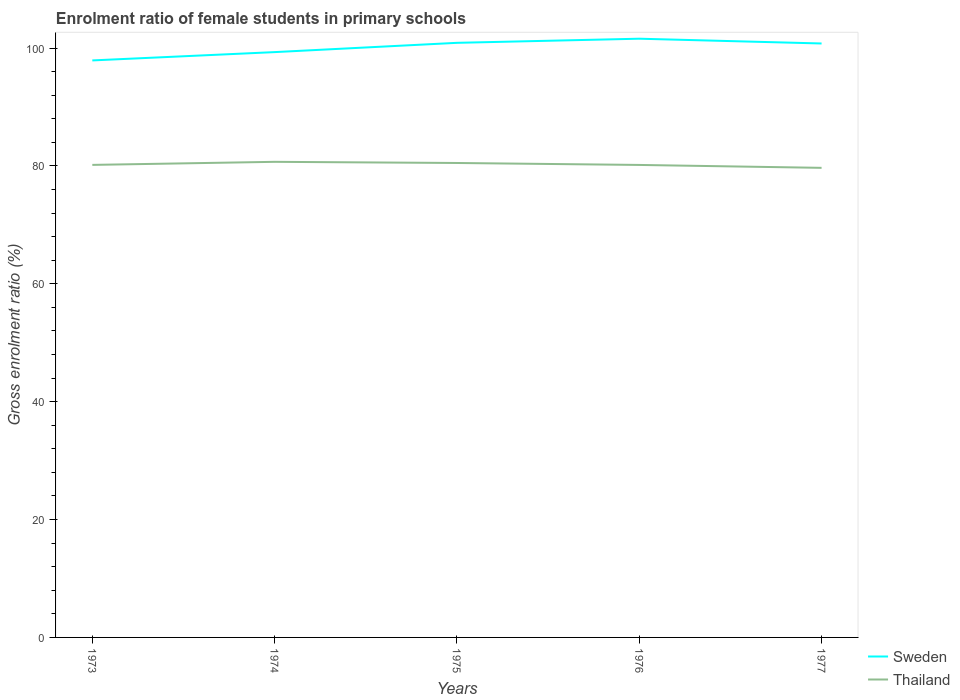How many different coloured lines are there?
Offer a terse response. 2. Across all years, what is the maximum enrolment ratio of female students in primary schools in Sweden?
Give a very brief answer. 97.91. What is the total enrolment ratio of female students in primary schools in Sweden in the graph?
Provide a short and direct response. -1.41. What is the difference between the highest and the second highest enrolment ratio of female students in primary schools in Sweden?
Give a very brief answer. 3.69. Is the enrolment ratio of female students in primary schools in Thailand strictly greater than the enrolment ratio of female students in primary schools in Sweden over the years?
Offer a terse response. Yes. How many years are there in the graph?
Provide a short and direct response. 5. Where does the legend appear in the graph?
Your answer should be very brief. Bottom right. How many legend labels are there?
Offer a terse response. 2. How are the legend labels stacked?
Ensure brevity in your answer.  Vertical. What is the title of the graph?
Provide a short and direct response. Enrolment ratio of female students in primary schools. What is the Gross enrolment ratio (%) of Sweden in 1973?
Make the answer very short. 97.91. What is the Gross enrolment ratio (%) of Thailand in 1973?
Make the answer very short. 80.18. What is the Gross enrolment ratio (%) of Sweden in 1974?
Give a very brief answer. 99.32. What is the Gross enrolment ratio (%) of Thailand in 1974?
Provide a short and direct response. 80.7. What is the Gross enrolment ratio (%) in Sweden in 1975?
Provide a short and direct response. 100.89. What is the Gross enrolment ratio (%) in Thailand in 1975?
Keep it short and to the point. 80.51. What is the Gross enrolment ratio (%) of Sweden in 1976?
Your response must be concise. 101.59. What is the Gross enrolment ratio (%) in Thailand in 1976?
Your answer should be very brief. 80.17. What is the Gross enrolment ratio (%) of Sweden in 1977?
Your answer should be compact. 100.78. What is the Gross enrolment ratio (%) of Thailand in 1977?
Keep it short and to the point. 79.68. Across all years, what is the maximum Gross enrolment ratio (%) in Sweden?
Offer a terse response. 101.59. Across all years, what is the maximum Gross enrolment ratio (%) of Thailand?
Your answer should be very brief. 80.7. Across all years, what is the minimum Gross enrolment ratio (%) in Sweden?
Provide a succinct answer. 97.91. Across all years, what is the minimum Gross enrolment ratio (%) of Thailand?
Your response must be concise. 79.68. What is the total Gross enrolment ratio (%) in Sweden in the graph?
Offer a terse response. 500.49. What is the total Gross enrolment ratio (%) of Thailand in the graph?
Offer a very short reply. 401.24. What is the difference between the Gross enrolment ratio (%) in Sweden in 1973 and that in 1974?
Provide a succinct answer. -1.41. What is the difference between the Gross enrolment ratio (%) of Thailand in 1973 and that in 1974?
Your response must be concise. -0.52. What is the difference between the Gross enrolment ratio (%) in Sweden in 1973 and that in 1975?
Ensure brevity in your answer.  -2.99. What is the difference between the Gross enrolment ratio (%) in Thailand in 1973 and that in 1975?
Make the answer very short. -0.33. What is the difference between the Gross enrolment ratio (%) of Sweden in 1973 and that in 1976?
Offer a terse response. -3.69. What is the difference between the Gross enrolment ratio (%) in Thailand in 1973 and that in 1976?
Make the answer very short. 0.01. What is the difference between the Gross enrolment ratio (%) of Sweden in 1973 and that in 1977?
Your answer should be compact. -2.88. What is the difference between the Gross enrolment ratio (%) in Thailand in 1973 and that in 1977?
Keep it short and to the point. 0.5. What is the difference between the Gross enrolment ratio (%) of Sweden in 1974 and that in 1975?
Keep it short and to the point. -1.57. What is the difference between the Gross enrolment ratio (%) in Thailand in 1974 and that in 1975?
Your answer should be very brief. 0.2. What is the difference between the Gross enrolment ratio (%) of Sweden in 1974 and that in 1976?
Keep it short and to the point. -2.27. What is the difference between the Gross enrolment ratio (%) in Thailand in 1974 and that in 1976?
Offer a terse response. 0.53. What is the difference between the Gross enrolment ratio (%) in Sweden in 1974 and that in 1977?
Make the answer very short. -1.46. What is the difference between the Gross enrolment ratio (%) of Thailand in 1974 and that in 1977?
Your response must be concise. 1.02. What is the difference between the Gross enrolment ratio (%) in Sweden in 1975 and that in 1976?
Offer a very short reply. -0.7. What is the difference between the Gross enrolment ratio (%) of Thailand in 1975 and that in 1976?
Give a very brief answer. 0.33. What is the difference between the Gross enrolment ratio (%) in Sweden in 1975 and that in 1977?
Your response must be concise. 0.11. What is the difference between the Gross enrolment ratio (%) in Thailand in 1975 and that in 1977?
Keep it short and to the point. 0.83. What is the difference between the Gross enrolment ratio (%) in Sweden in 1976 and that in 1977?
Keep it short and to the point. 0.81. What is the difference between the Gross enrolment ratio (%) in Thailand in 1976 and that in 1977?
Offer a terse response. 0.49. What is the difference between the Gross enrolment ratio (%) in Sweden in 1973 and the Gross enrolment ratio (%) in Thailand in 1974?
Your answer should be compact. 17.21. What is the difference between the Gross enrolment ratio (%) of Sweden in 1973 and the Gross enrolment ratio (%) of Thailand in 1975?
Give a very brief answer. 17.4. What is the difference between the Gross enrolment ratio (%) of Sweden in 1973 and the Gross enrolment ratio (%) of Thailand in 1976?
Make the answer very short. 17.73. What is the difference between the Gross enrolment ratio (%) of Sweden in 1973 and the Gross enrolment ratio (%) of Thailand in 1977?
Make the answer very short. 18.23. What is the difference between the Gross enrolment ratio (%) in Sweden in 1974 and the Gross enrolment ratio (%) in Thailand in 1975?
Your answer should be very brief. 18.81. What is the difference between the Gross enrolment ratio (%) of Sweden in 1974 and the Gross enrolment ratio (%) of Thailand in 1976?
Offer a very short reply. 19.15. What is the difference between the Gross enrolment ratio (%) of Sweden in 1974 and the Gross enrolment ratio (%) of Thailand in 1977?
Your response must be concise. 19.64. What is the difference between the Gross enrolment ratio (%) of Sweden in 1975 and the Gross enrolment ratio (%) of Thailand in 1976?
Provide a succinct answer. 20.72. What is the difference between the Gross enrolment ratio (%) in Sweden in 1975 and the Gross enrolment ratio (%) in Thailand in 1977?
Offer a very short reply. 21.21. What is the difference between the Gross enrolment ratio (%) of Sweden in 1976 and the Gross enrolment ratio (%) of Thailand in 1977?
Your answer should be very brief. 21.91. What is the average Gross enrolment ratio (%) in Sweden per year?
Your response must be concise. 100.1. What is the average Gross enrolment ratio (%) of Thailand per year?
Keep it short and to the point. 80.25. In the year 1973, what is the difference between the Gross enrolment ratio (%) of Sweden and Gross enrolment ratio (%) of Thailand?
Give a very brief answer. 17.73. In the year 1974, what is the difference between the Gross enrolment ratio (%) of Sweden and Gross enrolment ratio (%) of Thailand?
Your answer should be very brief. 18.62. In the year 1975, what is the difference between the Gross enrolment ratio (%) in Sweden and Gross enrolment ratio (%) in Thailand?
Give a very brief answer. 20.39. In the year 1976, what is the difference between the Gross enrolment ratio (%) in Sweden and Gross enrolment ratio (%) in Thailand?
Keep it short and to the point. 21.42. In the year 1977, what is the difference between the Gross enrolment ratio (%) of Sweden and Gross enrolment ratio (%) of Thailand?
Give a very brief answer. 21.1. What is the ratio of the Gross enrolment ratio (%) of Sweden in 1973 to that in 1974?
Make the answer very short. 0.99. What is the ratio of the Gross enrolment ratio (%) of Thailand in 1973 to that in 1974?
Keep it short and to the point. 0.99. What is the ratio of the Gross enrolment ratio (%) of Sweden in 1973 to that in 1975?
Keep it short and to the point. 0.97. What is the ratio of the Gross enrolment ratio (%) of Thailand in 1973 to that in 1975?
Give a very brief answer. 1. What is the ratio of the Gross enrolment ratio (%) in Sweden in 1973 to that in 1976?
Keep it short and to the point. 0.96. What is the ratio of the Gross enrolment ratio (%) of Sweden in 1973 to that in 1977?
Your response must be concise. 0.97. What is the ratio of the Gross enrolment ratio (%) in Thailand in 1973 to that in 1977?
Your answer should be compact. 1.01. What is the ratio of the Gross enrolment ratio (%) of Sweden in 1974 to that in 1975?
Provide a succinct answer. 0.98. What is the ratio of the Gross enrolment ratio (%) in Thailand in 1974 to that in 1975?
Keep it short and to the point. 1. What is the ratio of the Gross enrolment ratio (%) of Sweden in 1974 to that in 1976?
Make the answer very short. 0.98. What is the ratio of the Gross enrolment ratio (%) in Thailand in 1974 to that in 1976?
Make the answer very short. 1.01. What is the ratio of the Gross enrolment ratio (%) in Sweden in 1974 to that in 1977?
Your answer should be very brief. 0.99. What is the ratio of the Gross enrolment ratio (%) of Thailand in 1974 to that in 1977?
Keep it short and to the point. 1.01. What is the ratio of the Gross enrolment ratio (%) in Sweden in 1975 to that in 1977?
Your answer should be very brief. 1. What is the ratio of the Gross enrolment ratio (%) in Thailand in 1975 to that in 1977?
Offer a very short reply. 1.01. What is the difference between the highest and the second highest Gross enrolment ratio (%) in Sweden?
Keep it short and to the point. 0.7. What is the difference between the highest and the second highest Gross enrolment ratio (%) of Thailand?
Ensure brevity in your answer.  0.2. What is the difference between the highest and the lowest Gross enrolment ratio (%) in Sweden?
Offer a very short reply. 3.69. What is the difference between the highest and the lowest Gross enrolment ratio (%) of Thailand?
Provide a succinct answer. 1.02. 